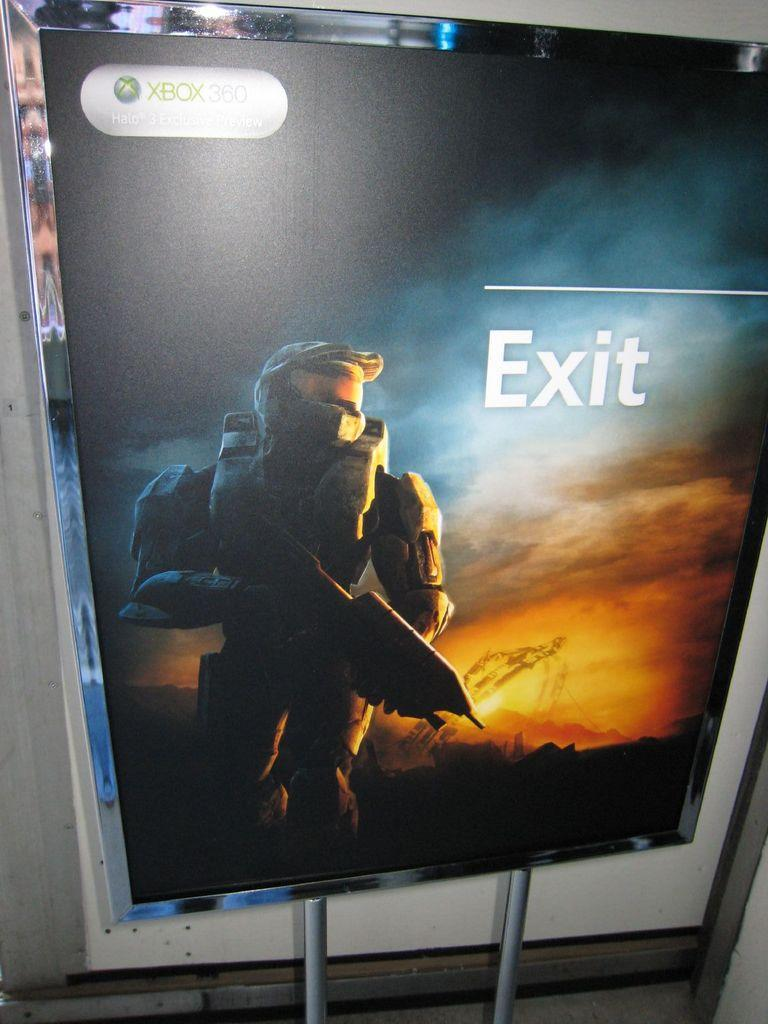<image>
Present a compact description of the photo's key features. Exit the real world, and enter the world of Halo on Xbox 360 